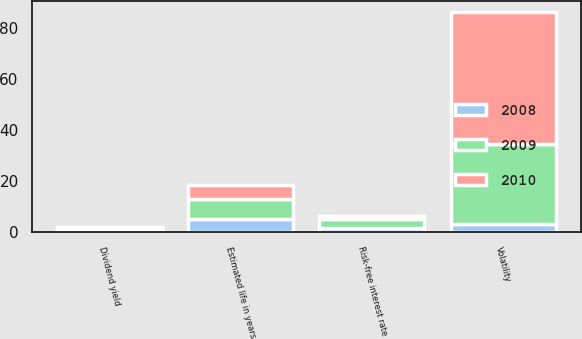Convert chart. <chart><loc_0><loc_0><loc_500><loc_500><stacked_bar_chart><ecel><fcel>Risk-free interest rate<fcel>Estimated life in years<fcel>Dividend yield<fcel>Volatility<nl><fcel>2010<fcel>1.27<fcel>5.72<fcel>0.59<fcel>51.75<nl><fcel>2008<fcel>1.9<fcel>5.2<fcel>0.96<fcel>3.3<nl><fcel>2009<fcel>3.3<fcel>7.7<fcel>0.38<fcel>31.4<nl></chart> 